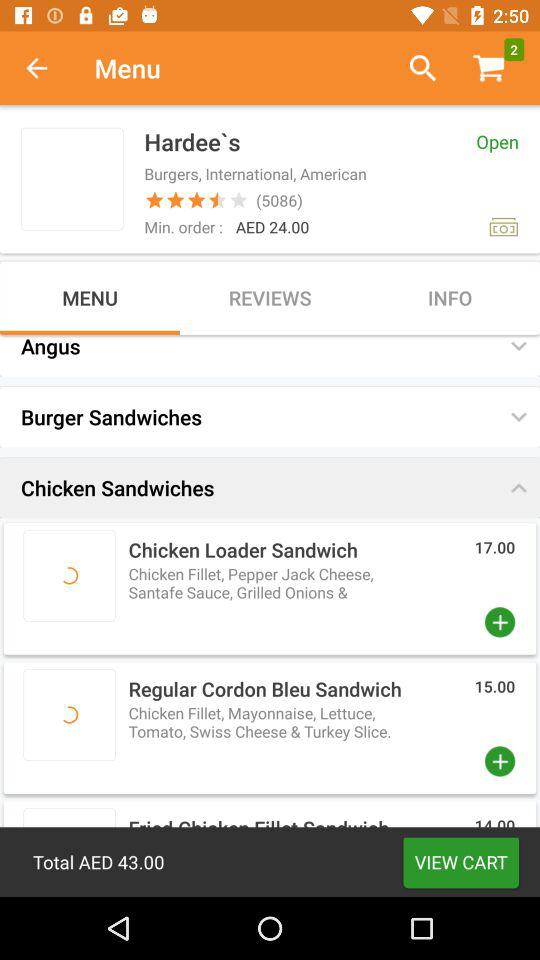How many things are added to the cart? The things added to the cart are 2. 